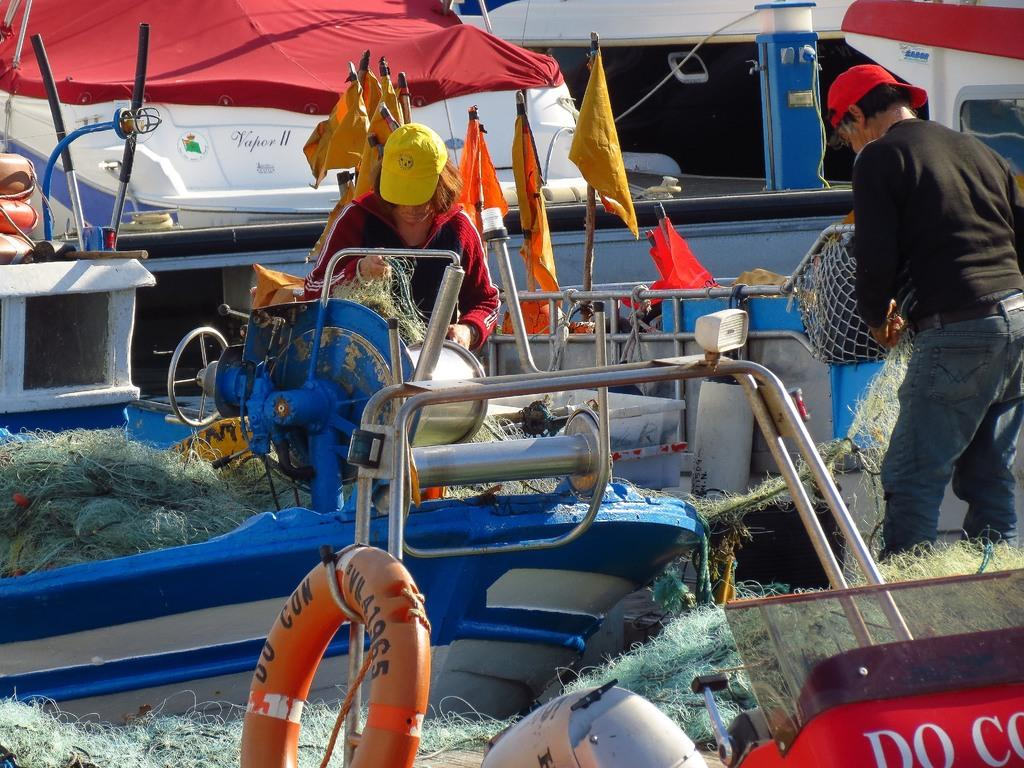How many people are in the image? There are two people in the image. What are the people wearing? The people are wearing dresses and caps. What can be seen in the image related to water transportation? There are boats in the image. What are the flags used for in the image? The flags are used for identification or decoration in the image. What objects are used for catching fish in the image? Fishing-nets are present in the image. What are the tubes used for in the image? The purpose of the tubes in the image is not clear, but they might be used for storage or transportation. How many legs can be seen in the image? The number of legs visible in the image cannot be determined from the provided facts, as the focus is on the people's attire and the objects around them. --- Facts: 1. There is a person holding a book in the image. 2. The person is sitting on a chair. 3. There is a table in the image. 4. The table has a lamp on it. 5. The background of the image is a wall. Absurd Topics: elephant, dance, ocean Conversation: What is the person in the image holding? The person is holding a book in the image. What is the person sitting on? The person is sitting on a chair in the image. What can be seen on the table in the image? The table has a lamp on it in the image. What is the background of the image? The background of the image is a wall. Reasoning: Let's think step by step in order to produce the conversation. We start by identifying the main subject in the image, which is the person holding a book. Then, we describe the person's position and the objects around them, such as the chair and the table with a lamp. Finally, we mention the background of the image, which is a wall. Absurd Question/Answer: Can you see an elephant dancing in the ocean in the image? No, there is no elephant, dancing, or ocean present in the image. 